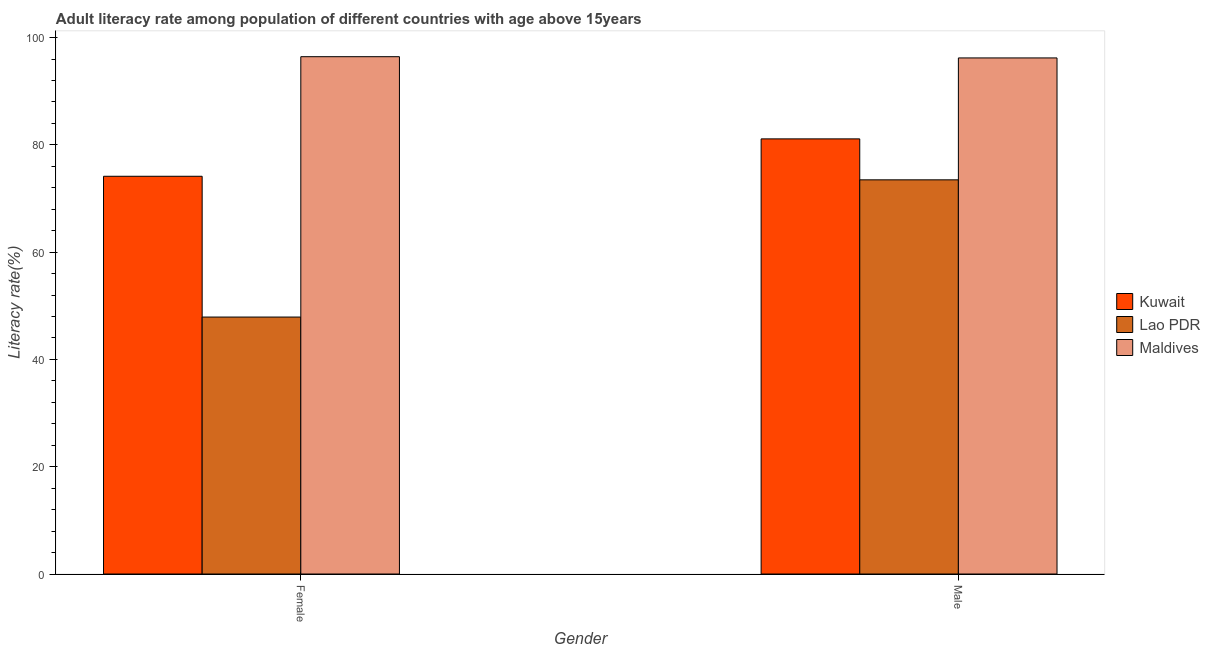Are the number of bars per tick equal to the number of legend labels?
Give a very brief answer. Yes. Are the number of bars on each tick of the X-axis equal?
Ensure brevity in your answer.  Yes. What is the female adult literacy rate in Kuwait?
Offer a terse response. 74.15. Across all countries, what is the maximum female adult literacy rate?
Keep it short and to the point. 96.44. Across all countries, what is the minimum female adult literacy rate?
Offer a very short reply. 47.9. In which country was the female adult literacy rate maximum?
Give a very brief answer. Maldives. In which country was the male adult literacy rate minimum?
Give a very brief answer. Lao PDR. What is the total male adult literacy rate in the graph?
Give a very brief answer. 250.82. What is the difference between the male adult literacy rate in Lao PDR and that in Kuwait?
Offer a very short reply. -7.63. What is the difference between the male adult literacy rate in Kuwait and the female adult literacy rate in Maldives?
Provide a succinct answer. -15.32. What is the average female adult literacy rate per country?
Give a very brief answer. 72.83. What is the difference between the male adult literacy rate and female adult literacy rate in Kuwait?
Offer a terse response. 6.97. In how many countries, is the male adult literacy rate greater than 24 %?
Provide a succinct answer. 3. What is the ratio of the male adult literacy rate in Lao PDR to that in Maldives?
Give a very brief answer. 0.76. Is the male adult literacy rate in Lao PDR less than that in Kuwait?
Your response must be concise. Yes. What does the 3rd bar from the left in Female represents?
Make the answer very short. Maldives. What does the 1st bar from the right in Female represents?
Your response must be concise. Maldives. How many countries are there in the graph?
Your answer should be very brief. 3. Are the values on the major ticks of Y-axis written in scientific E-notation?
Your answer should be very brief. No. Does the graph contain any zero values?
Provide a short and direct response. No. Where does the legend appear in the graph?
Your response must be concise. Center right. What is the title of the graph?
Keep it short and to the point. Adult literacy rate among population of different countries with age above 15years. Does "Liechtenstein" appear as one of the legend labels in the graph?
Your answer should be very brief. No. What is the label or title of the Y-axis?
Make the answer very short. Literacy rate(%). What is the Literacy rate(%) of Kuwait in Female?
Offer a terse response. 74.15. What is the Literacy rate(%) of Lao PDR in Female?
Offer a very short reply. 47.9. What is the Literacy rate(%) of Maldives in Female?
Your answer should be compact. 96.44. What is the Literacy rate(%) in Kuwait in Male?
Provide a succinct answer. 81.12. What is the Literacy rate(%) in Lao PDR in Male?
Your answer should be very brief. 73.49. What is the Literacy rate(%) in Maldives in Male?
Offer a very short reply. 96.21. Across all Gender, what is the maximum Literacy rate(%) of Kuwait?
Offer a terse response. 81.12. Across all Gender, what is the maximum Literacy rate(%) in Lao PDR?
Provide a succinct answer. 73.49. Across all Gender, what is the maximum Literacy rate(%) of Maldives?
Provide a succinct answer. 96.44. Across all Gender, what is the minimum Literacy rate(%) of Kuwait?
Your answer should be compact. 74.15. Across all Gender, what is the minimum Literacy rate(%) of Lao PDR?
Offer a terse response. 47.9. Across all Gender, what is the minimum Literacy rate(%) in Maldives?
Offer a terse response. 96.21. What is the total Literacy rate(%) of Kuwait in the graph?
Your answer should be very brief. 155.27. What is the total Literacy rate(%) of Lao PDR in the graph?
Your answer should be compact. 121.39. What is the total Literacy rate(%) of Maldives in the graph?
Offer a terse response. 192.66. What is the difference between the Literacy rate(%) in Kuwait in Female and that in Male?
Your answer should be compact. -6.97. What is the difference between the Literacy rate(%) in Lao PDR in Female and that in Male?
Provide a succinct answer. -25.58. What is the difference between the Literacy rate(%) of Maldives in Female and that in Male?
Ensure brevity in your answer.  0.23. What is the difference between the Literacy rate(%) of Kuwait in Female and the Literacy rate(%) of Lao PDR in Male?
Keep it short and to the point. 0.66. What is the difference between the Literacy rate(%) of Kuwait in Female and the Literacy rate(%) of Maldives in Male?
Your answer should be very brief. -22.06. What is the difference between the Literacy rate(%) of Lao PDR in Female and the Literacy rate(%) of Maldives in Male?
Your answer should be very brief. -48.31. What is the average Literacy rate(%) in Kuwait per Gender?
Give a very brief answer. 77.63. What is the average Literacy rate(%) of Lao PDR per Gender?
Provide a succinct answer. 60.69. What is the average Literacy rate(%) of Maldives per Gender?
Provide a short and direct response. 96.33. What is the difference between the Literacy rate(%) in Kuwait and Literacy rate(%) in Lao PDR in Female?
Keep it short and to the point. 26.25. What is the difference between the Literacy rate(%) of Kuwait and Literacy rate(%) of Maldives in Female?
Offer a very short reply. -22.29. What is the difference between the Literacy rate(%) of Lao PDR and Literacy rate(%) of Maldives in Female?
Your answer should be compact. -48.54. What is the difference between the Literacy rate(%) of Kuwait and Literacy rate(%) of Lao PDR in Male?
Give a very brief answer. 7.63. What is the difference between the Literacy rate(%) of Kuwait and Literacy rate(%) of Maldives in Male?
Ensure brevity in your answer.  -15.09. What is the difference between the Literacy rate(%) in Lao PDR and Literacy rate(%) in Maldives in Male?
Make the answer very short. -22.73. What is the ratio of the Literacy rate(%) of Kuwait in Female to that in Male?
Ensure brevity in your answer.  0.91. What is the ratio of the Literacy rate(%) in Lao PDR in Female to that in Male?
Keep it short and to the point. 0.65. What is the difference between the highest and the second highest Literacy rate(%) in Kuwait?
Your response must be concise. 6.97. What is the difference between the highest and the second highest Literacy rate(%) of Lao PDR?
Give a very brief answer. 25.58. What is the difference between the highest and the second highest Literacy rate(%) in Maldives?
Offer a very short reply. 0.23. What is the difference between the highest and the lowest Literacy rate(%) in Kuwait?
Provide a short and direct response. 6.97. What is the difference between the highest and the lowest Literacy rate(%) of Lao PDR?
Provide a short and direct response. 25.58. What is the difference between the highest and the lowest Literacy rate(%) in Maldives?
Make the answer very short. 0.23. 